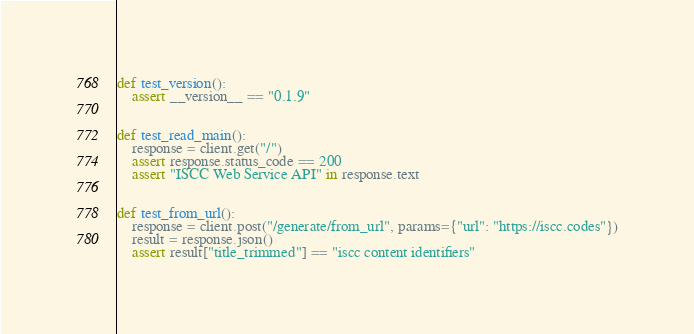Convert code to text. <code><loc_0><loc_0><loc_500><loc_500><_Python_>

def test_version():
    assert __version__ == "0.1.9"


def test_read_main():
    response = client.get("/")
    assert response.status_code == 200
    assert "ISCC Web Service API" in response.text


def test_from_url():
    response = client.post("/generate/from_url", params={"url": "https://iscc.codes"})
    result = response.json()
    assert result["title_trimmed"] == "iscc content identifiers"
</code> 